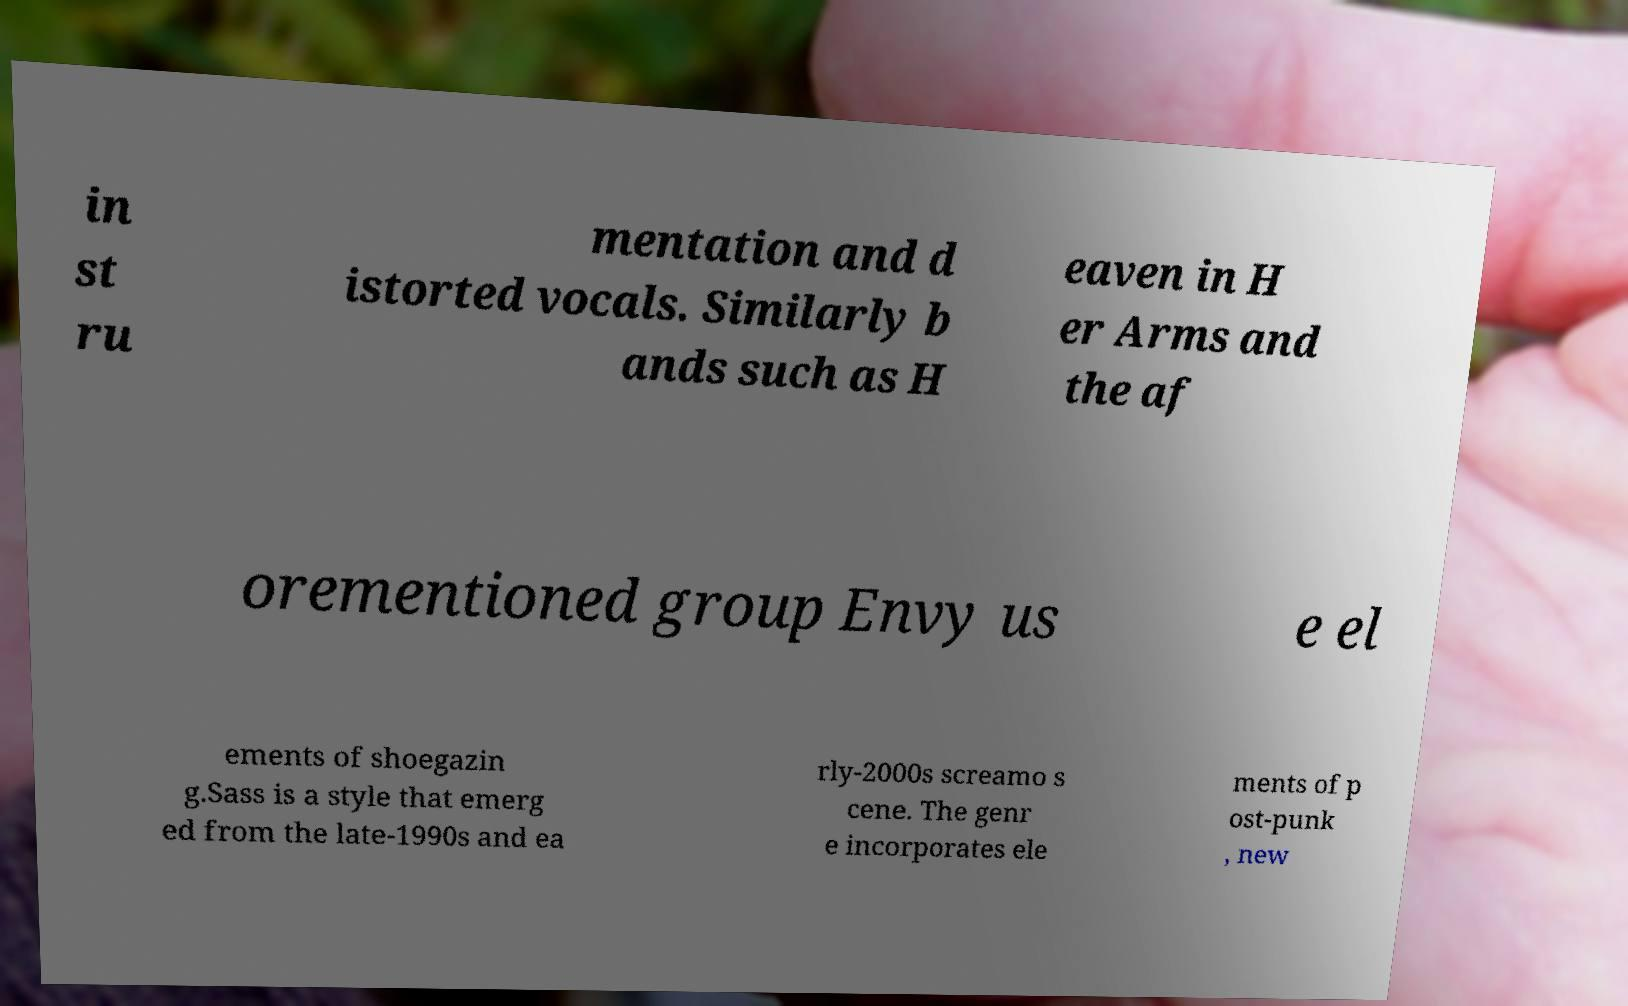For documentation purposes, I need the text within this image transcribed. Could you provide that? in st ru mentation and d istorted vocals. Similarly b ands such as H eaven in H er Arms and the af orementioned group Envy us e el ements of shoegazin g.Sass is a style that emerg ed from the late-1990s and ea rly-2000s screamo s cene. The genr e incorporates ele ments of p ost-punk , new 